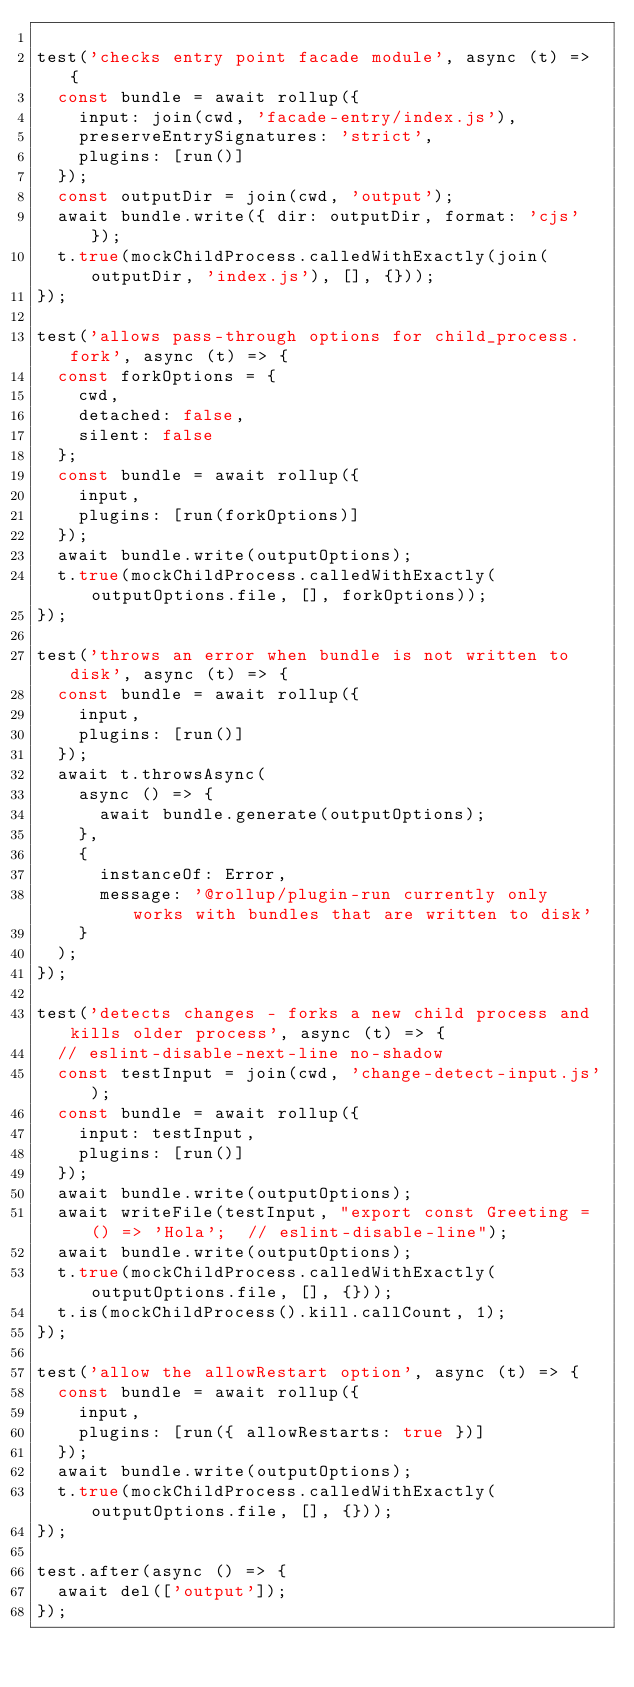Convert code to text. <code><loc_0><loc_0><loc_500><loc_500><_JavaScript_>
test('checks entry point facade module', async (t) => {
  const bundle = await rollup({
    input: join(cwd, 'facade-entry/index.js'),
    preserveEntrySignatures: 'strict',
    plugins: [run()]
  });
  const outputDir = join(cwd, 'output');
  await bundle.write({ dir: outputDir, format: 'cjs' });
  t.true(mockChildProcess.calledWithExactly(join(outputDir, 'index.js'), [], {}));
});

test('allows pass-through options for child_process.fork', async (t) => {
  const forkOptions = {
    cwd,
    detached: false,
    silent: false
  };
  const bundle = await rollup({
    input,
    plugins: [run(forkOptions)]
  });
  await bundle.write(outputOptions);
  t.true(mockChildProcess.calledWithExactly(outputOptions.file, [], forkOptions));
});

test('throws an error when bundle is not written to disk', async (t) => {
  const bundle = await rollup({
    input,
    plugins: [run()]
  });
  await t.throwsAsync(
    async () => {
      await bundle.generate(outputOptions);
    },
    {
      instanceOf: Error,
      message: '@rollup/plugin-run currently only works with bundles that are written to disk'
    }
  );
});

test('detects changes - forks a new child process and kills older process', async (t) => {
  // eslint-disable-next-line no-shadow
  const testInput = join(cwd, 'change-detect-input.js');
  const bundle = await rollup({
    input: testInput,
    plugins: [run()]
  });
  await bundle.write(outputOptions);
  await writeFile(testInput, "export const Greeting = () => 'Hola';  // eslint-disable-line");
  await bundle.write(outputOptions);
  t.true(mockChildProcess.calledWithExactly(outputOptions.file, [], {}));
  t.is(mockChildProcess().kill.callCount, 1);
});

test('allow the allowRestart option', async (t) => {
  const bundle = await rollup({
    input,
    plugins: [run({ allowRestarts: true })]
  });
  await bundle.write(outputOptions);
  t.true(mockChildProcess.calledWithExactly(outputOptions.file, [], {}));
});

test.after(async () => {
  await del(['output']);
});
</code> 